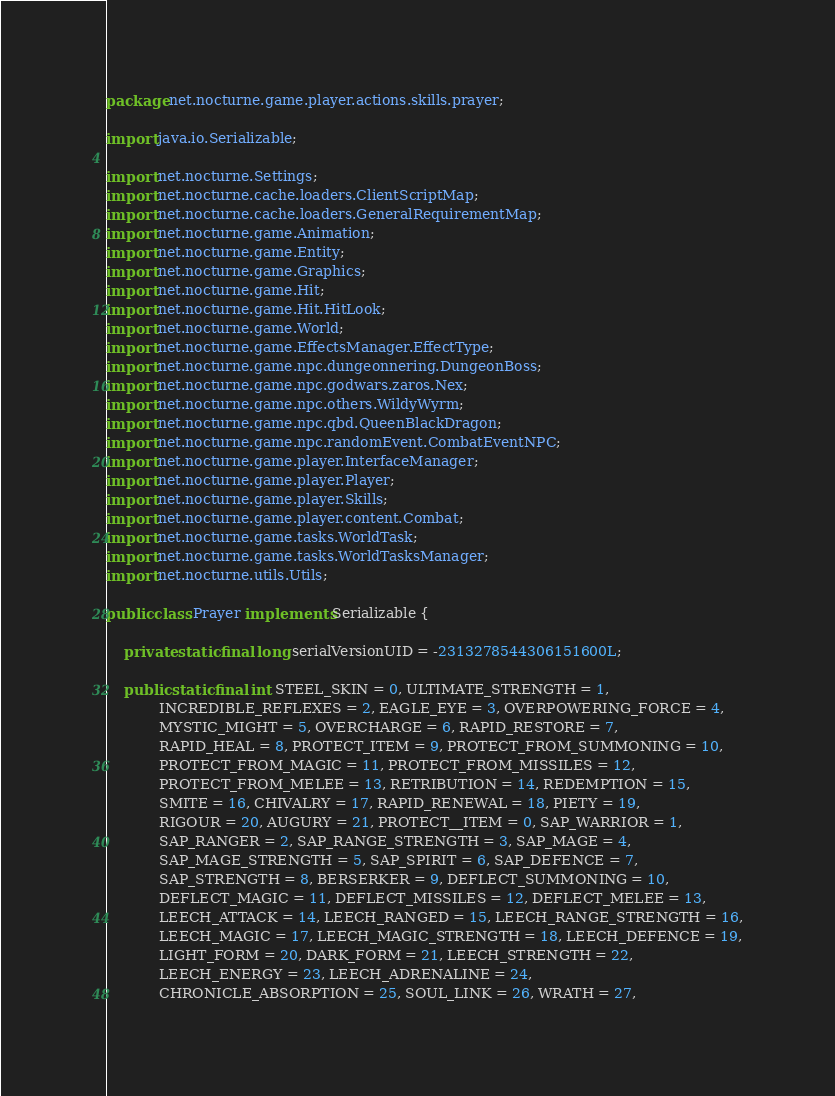<code> <loc_0><loc_0><loc_500><loc_500><_Java_>package net.nocturne.game.player.actions.skills.prayer;

import java.io.Serializable;

import net.nocturne.Settings;
import net.nocturne.cache.loaders.ClientScriptMap;
import net.nocturne.cache.loaders.GeneralRequirementMap;
import net.nocturne.game.Animation;
import net.nocturne.game.Entity;
import net.nocturne.game.Graphics;
import net.nocturne.game.Hit;
import net.nocturne.game.Hit.HitLook;
import net.nocturne.game.World;
import net.nocturne.game.EffectsManager.EffectType;
import net.nocturne.game.npc.dungeonnering.DungeonBoss;
import net.nocturne.game.npc.godwars.zaros.Nex;
import net.nocturne.game.npc.others.WildyWyrm;
import net.nocturne.game.npc.qbd.QueenBlackDragon;
import net.nocturne.game.npc.randomEvent.CombatEventNPC;
import net.nocturne.game.player.InterfaceManager;
import net.nocturne.game.player.Player;
import net.nocturne.game.player.Skills;
import net.nocturne.game.player.content.Combat;
import net.nocturne.game.tasks.WorldTask;
import net.nocturne.game.tasks.WorldTasksManager;
import net.nocturne.utils.Utils;

public class Prayer implements Serializable {

	private static final long serialVersionUID = -2313278544306151600L;

	public static final int STEEL_SKIN = 0, ULTIMATE_STRENGTH = 1,
			INCREDIBLE_REFLEXES = 2, EAGLE_EYE = 3, OVERPOWERING_FORCE = 4,
			MYSTIC_MIGHT = 5, OVERCHARGE = 6, RAPID_RESTORE = 7,
			RAPID_HEAL = 8, PROTECT_ITEM = 9, PROTECT_FROM_SUMMONING = 10,
			PROTECT_FROM_MAGIC = 11, PROTECT_FROM_MISSILES = 12,
			PROTECT_FROM_MELEE = 13, RETRIBUTION = 14, REDEMPTION = 15,
			SMITE = 16, CHIVALRY = 17, RAPID_RENEWAL = 18, PIETY = 19,
			RIGOUR = 20, AUGURY = 21, PROTECT__ITEM = 0, SAP_WARRIOR = 1,
			SAP_RANGER = 2, SAP_RANGE_STRENGTH = 3, SAP_MAGE = 4,
			SAP_MAGE_STRENGTH = 5, SAP_SPIRIT = 6, SAP_DEFENCE = 7,
			SAP_STRENGTH = 8, BERSERKER = 9, DEFLECT_SUMMONING = 10,
			DEFLECT_MAGIC = 11, DEFLECT_MISSILES = 12, DEFLECT_MELEE = 13,
			LEECH_ATTACK = 14, LEECH_RANGED = 15, LEECH_RANGE_STRENGTH = 16,
			LEECH_MAGIC = 17, LEECH_MAGIC_STRENGTH = 18, LEECH_DEFENCE = 19,
			LIGHT_FORM = 20, DARK_FORM = 21, LEECH_STRENGTH = 22,
			LEECH_ENERGY = 23, LEECH_ADRENALINE = 24,
			CHRONICLE_ABSORPTION = 25, SOUL_LINK = 26, WRATH = 27,</code> 